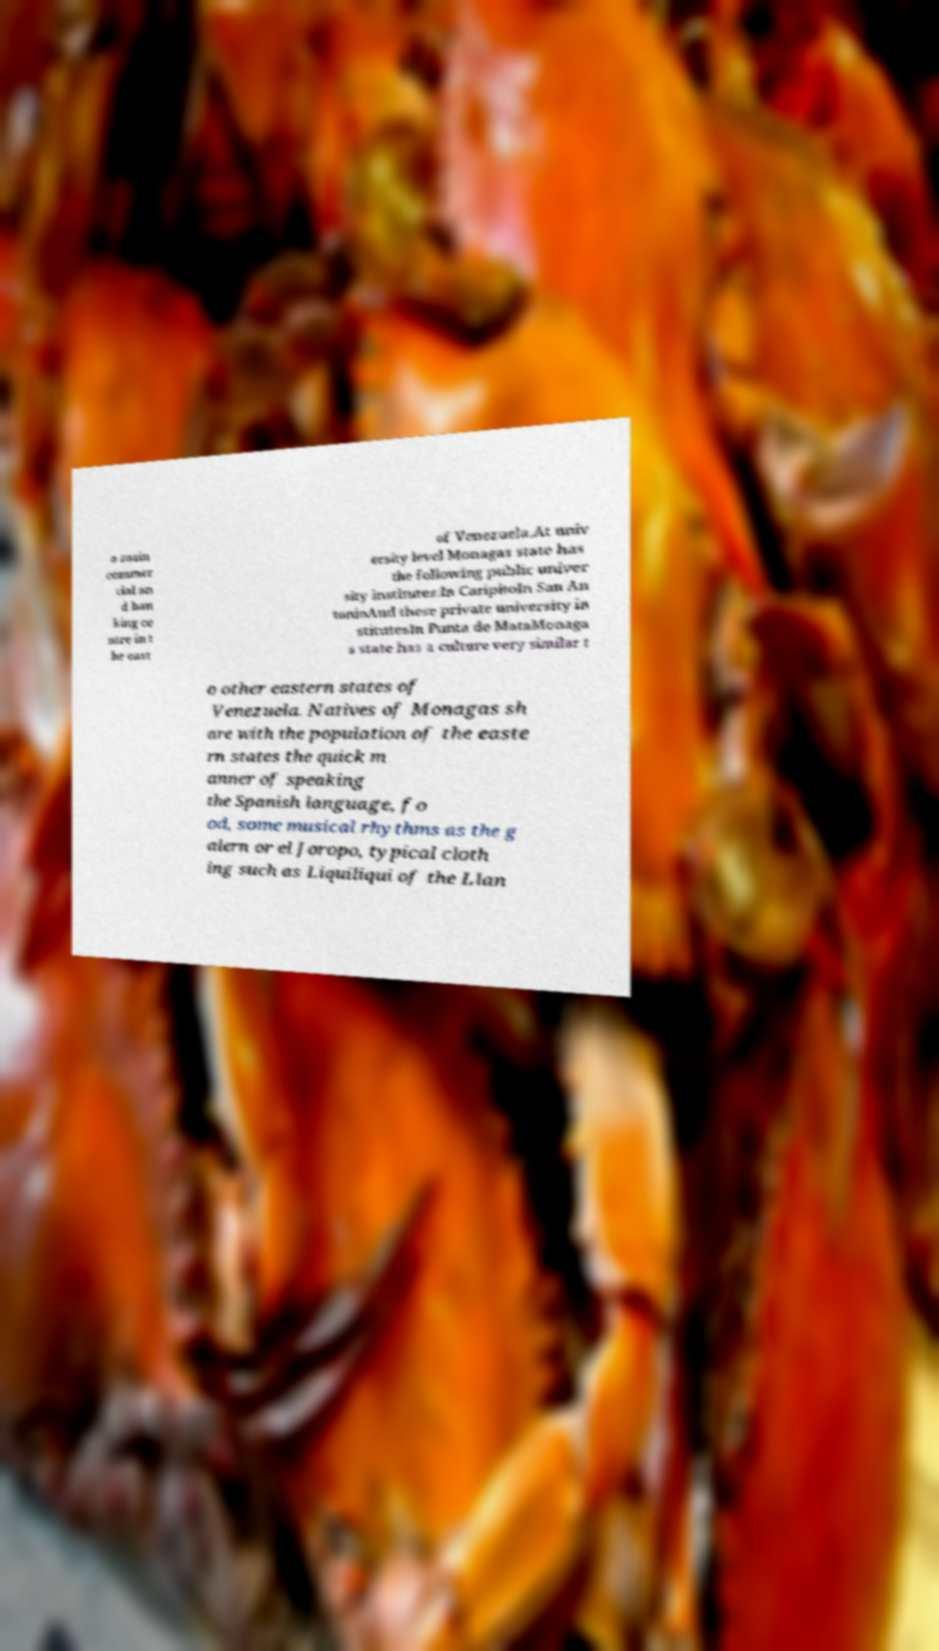Please read and relay the text visible in this image. What does it say? a main commer cial an d ban king ce ntre in t he east of Venezuela.At univ ersity level Monagas state has the following public univer sity institutes:In CaripitoIn San An tonioAnd these private university in stitutesIn Punta de MataMonaga s state has a culture very similar t o other eastern states of Venezuela. Natives of Monagas sh are with the population of the easte rn states the quick m anner of speaking the Spanish language, fo od, some musical rhythms as the g alern or el Joropo, typical cloth ing such as Liquiliqui of the Llan 